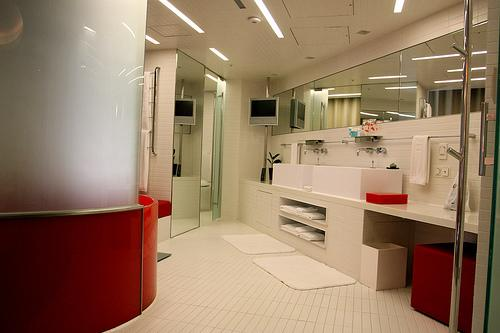Describe the color of the box and its content, if any. There is a closed red box in the image, and its content is not visible. List any electronic gadgets present in the image. There is a silver television hanging from the ceiling and a video monitor mounted on the ceiling. Describe any seating arrangements available in the image. There is a cube-shaped red ottoman under the counter that serves as a seat. Provide a brief description of the mirror(s) present in the image. There are large mirrors mounted on the wall and ceiling, as well as a floor-to-ceiling mirror. Explain the lighting situation in the image. The lights in the ceiling are on, providing illumination to the room. Describe any waste disposal options visible in the image. There is a white trash receptacle placed in the bathroom for waste disposal. Express the type of flooring in the image in a short sentence. The bathroom has tiled flooring, with two large white bathroom rugs on it. Mention the most prominent feature of the room in the image. The room is mostly white, featuring a red and white bathroom with two white sinks. Give a brief about the storage arrangements for towels in the image. There are folded towels on shelves, and white towels are stored under the vanity. In the image, describe any signs of plants or other living things. There is a small plant in a pot placed near the sink. 